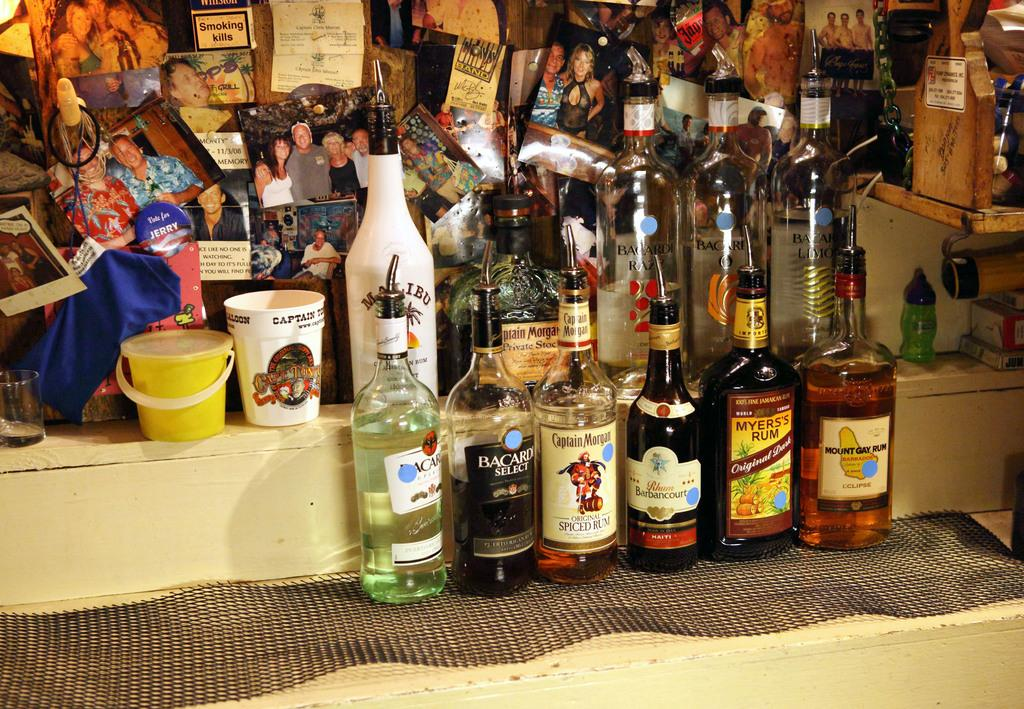<image>
Offer a succinct explanation of the picture presented. A bottle of captain morgan liquor sits on the floor. 